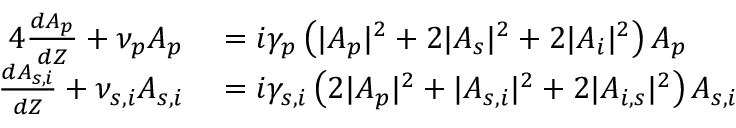Convert formula to latex. <formula><loc_0><loc_0><loc_500><loc_500>\begin{array} { r l } { { 4 } \frac { d A _ { p } } { d Z } + \nu _ { p } A _ { p } } & = i \gamma _ { p } \left ( | A _ { p } | ^ { 2 } + 2 | A _ { s } | ^ { 2 } + 2 | A _ { i } | ^ { 2 } \right ) A _ { p } } \\ { \frac { d A _ { s , i } } { d Z } + \nu _ { s , i } A _ { s , i } } & = i \gamma _ { s , i } \left ( 2 | A _ { p } | ^ { 2 } + | A _ { s , i } | ^ { 2 } + 2 | A _ { i , s } | ^ { 2 } \right ) A _ { s , i } } \end{array}</formula> 